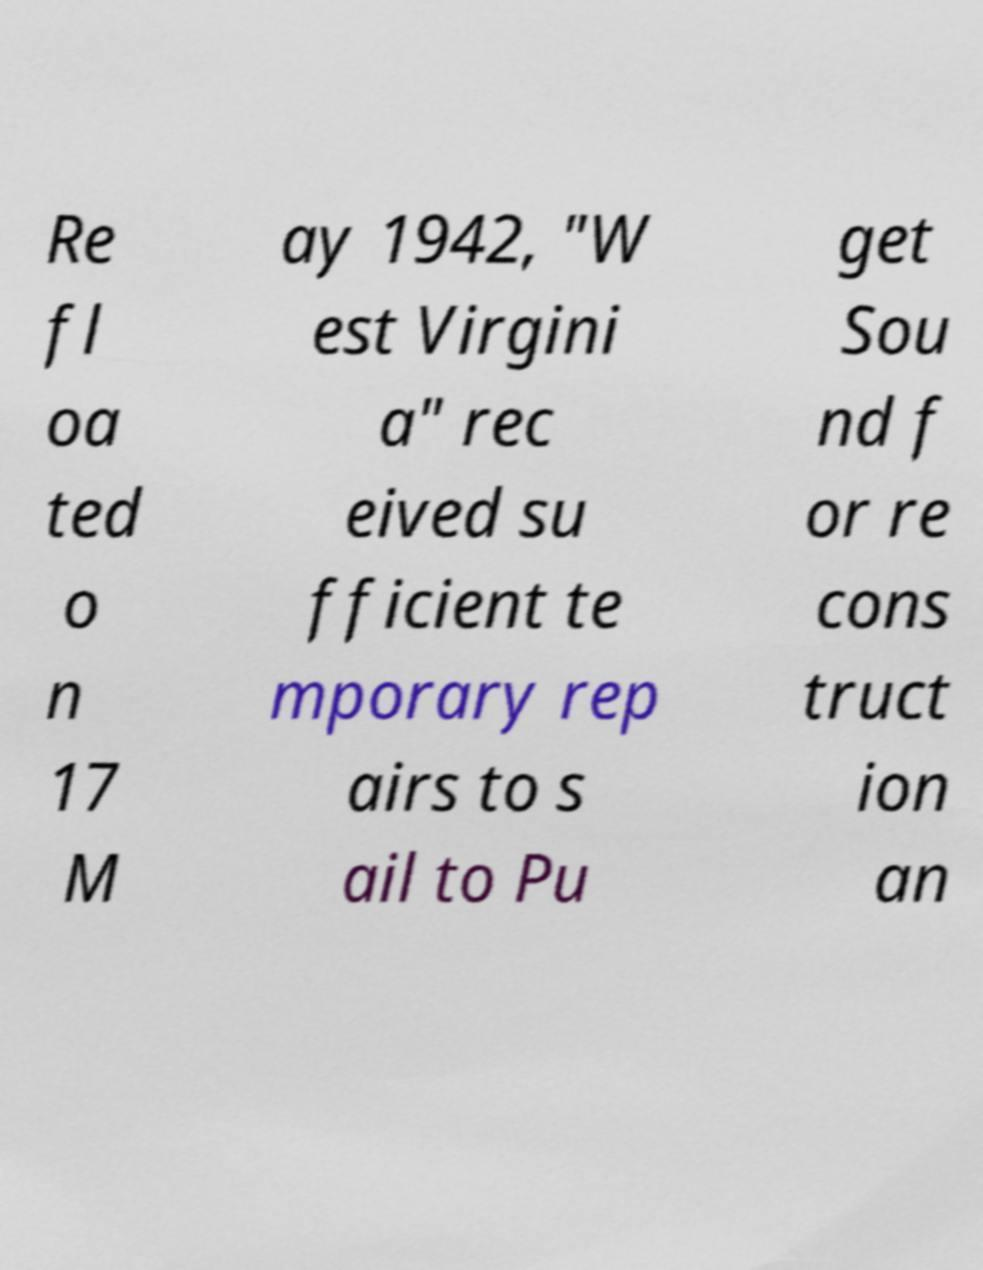Please read and relay the text visible in this image. What does it say? Re fl oa ted o n 17 M ay 1942, "W est Virgini a" rec eived su fficient te mporary rep airs to s ail to Pu get Sou nd f or re cons truct ion an 